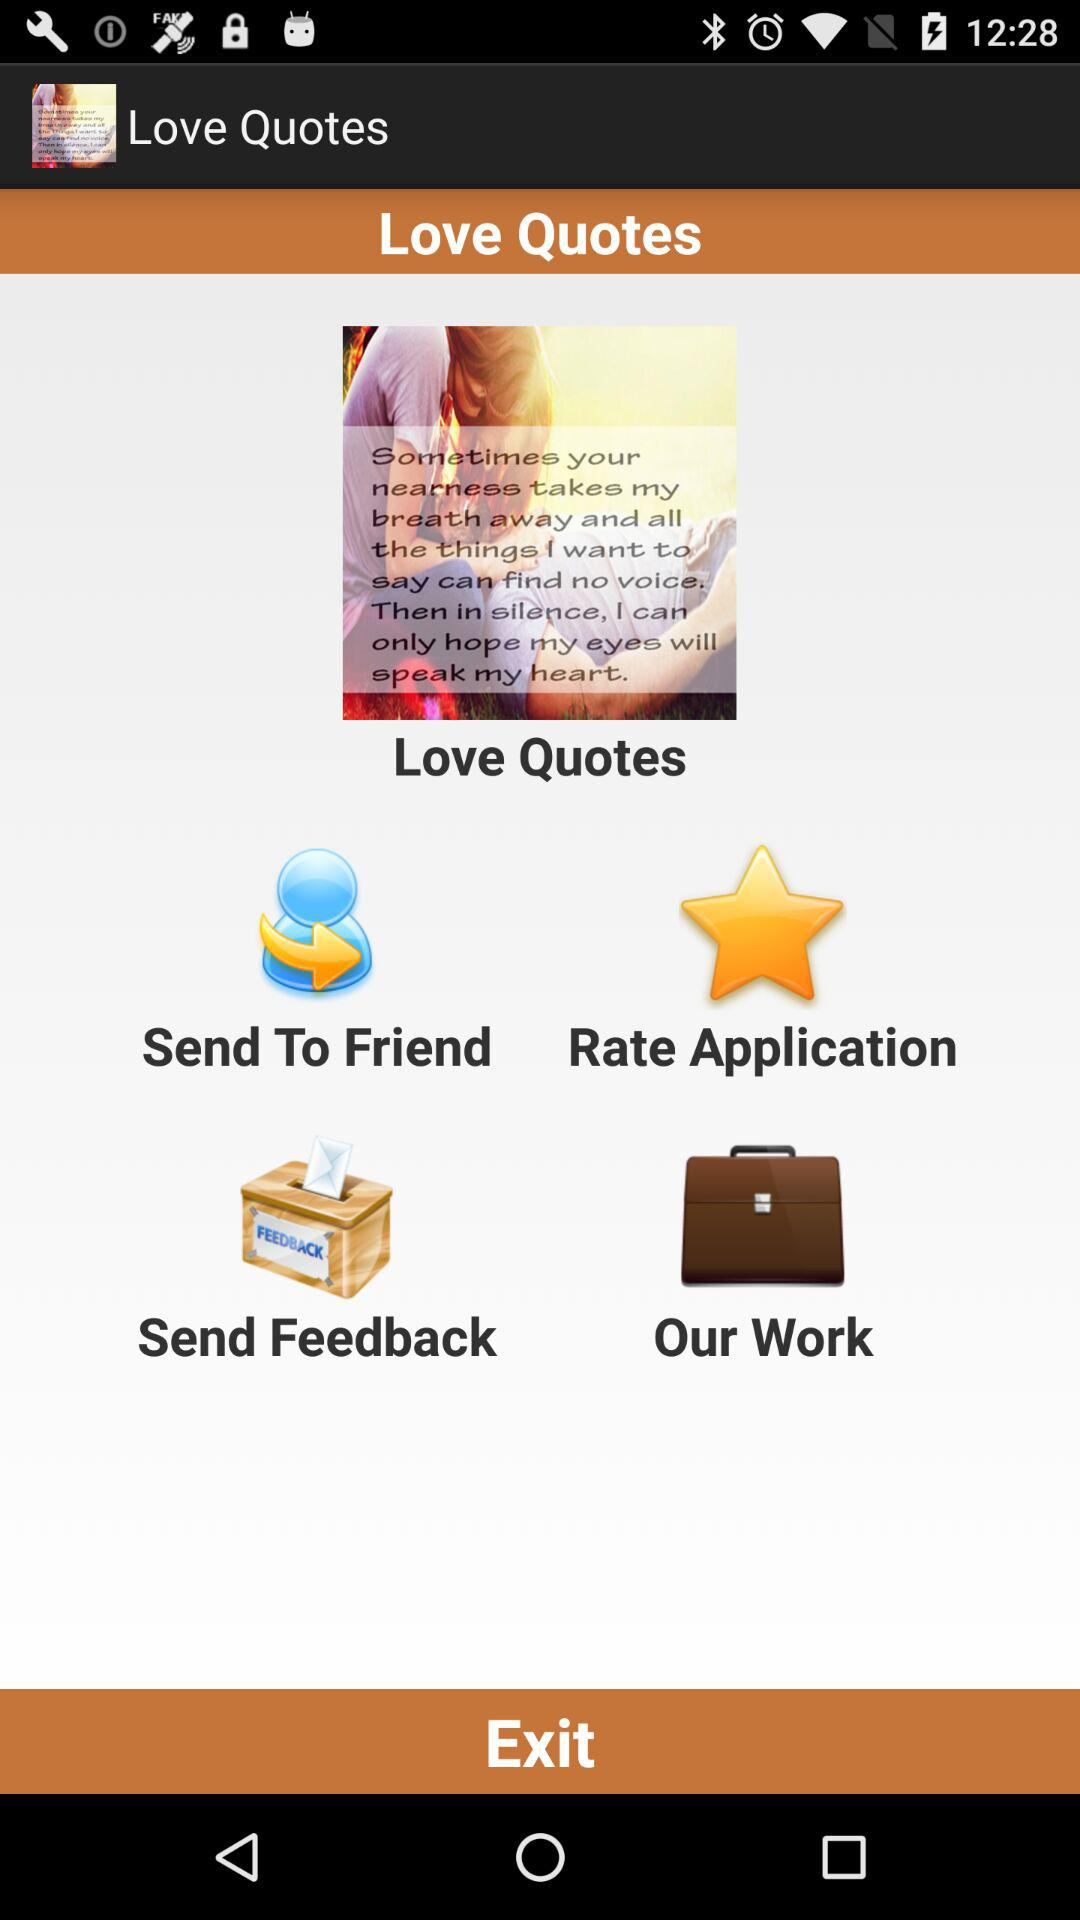What is the application name? The application name is "Love Quotes". 